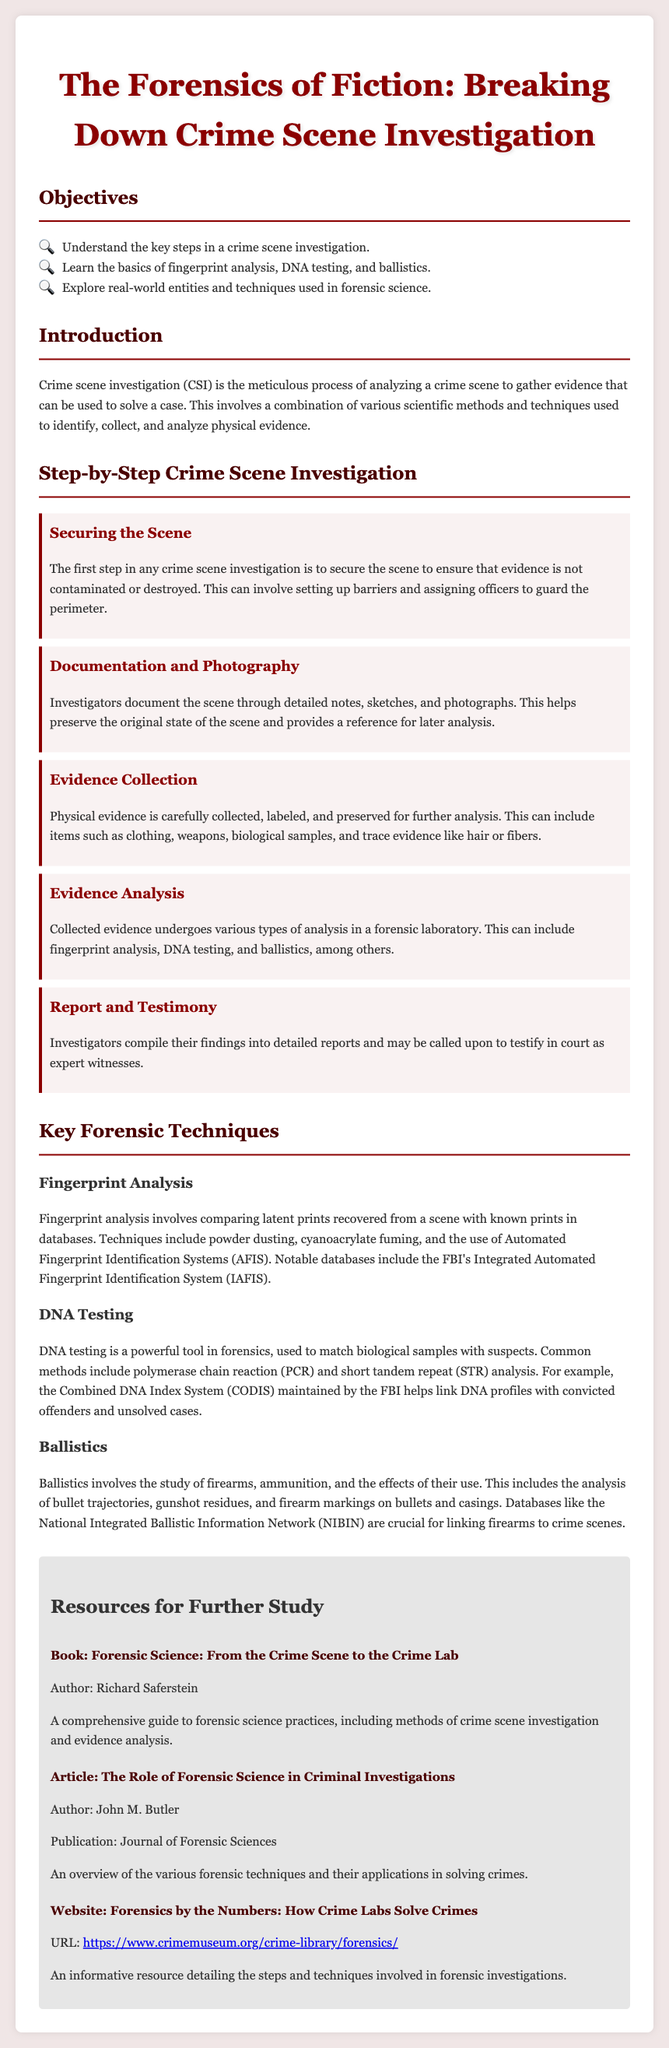what is the first step in crime scene investigation? The first step in any crime scene investigation is to secure the scene to ensure that evidence is not contaminated or destroyed.
Answer: Securing the Scene what analysis method is used for fingerprint analysis? Fingerprint analysis involves comparing latent prints recovered from a scene with known prints in databases using techniques like powder dusting.
Answer: Powder dusting what does DNA testing help match? DNA testing is a powerful tool in forensics, used to match biological samples with suspects.
Answer: Biological samples what does ballistics study? Ballistics involves the study of firearms, ammunition, and the effects of their use.
Answer: Firearms which database helps link DNA profiles? The Combined DNA Index System (CODIS) maintained by the FBI helps link DNA profiles with convicted offenders.
Answer: CODIS what kind of evidence can be collected in a crime scene investigation? Physical evidence can include items such as clothing, weapons, biological samples, and trace evidence like hair or fibers.
Answer: Clothing, weapons, biological samples, trace evidence who is the author of the book listed in the resources? The author of the book "Forensic Science: From the Crime Scene to the Crime Lab" is Richard Saferstein.
Answer: Richard Saferstein what is documented through detailed notes and sketches? Investigators document the scene through detailed notes, sketches, and photographs to preserve its original state.
Answer: The scene how can investigators testify about their findings? Investigators compile their findings into detailed reports and may be called upon to testify in court as expert witnesses.
Answer: Testify in court which technique is used in DNA testing? Common methods in DNA testing include polymerase chain reaction (PCR) and short tandem repeat (STR) analysis.
Answer: PCR, STR analysis 